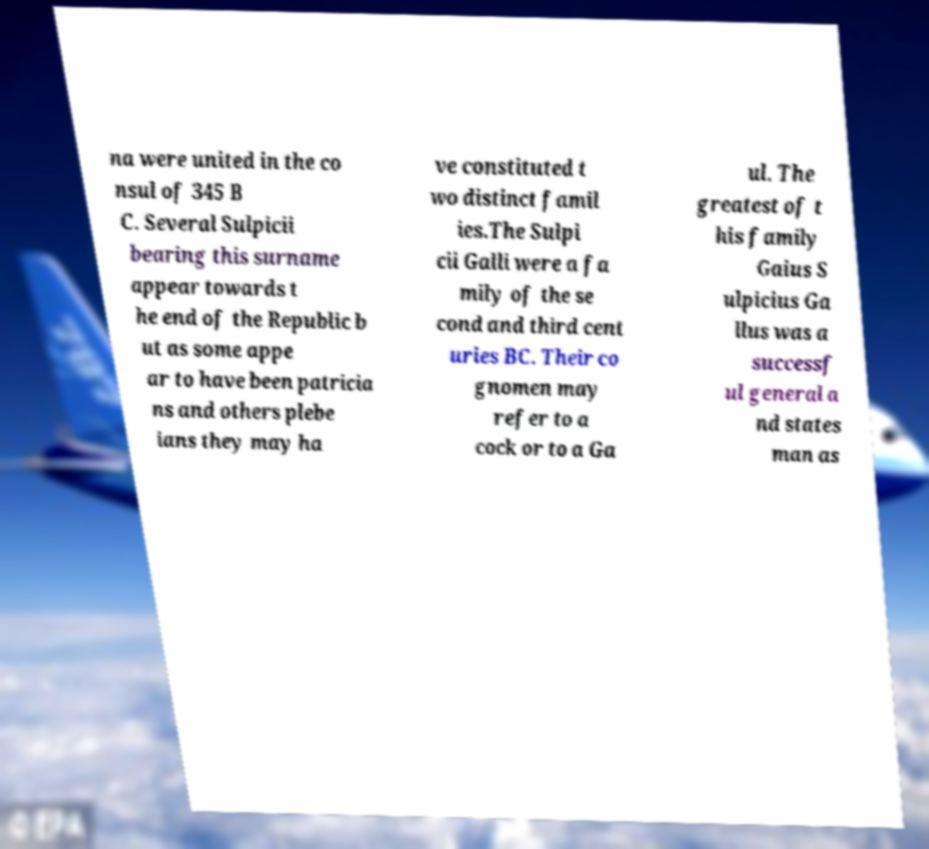Could you extract and type out the text from this image? na were united in the co nsul of 345 B C. Several Sulpicii bearing this surname appear towards t he end of the Republic b ut as some appe ar to have been patricia ns and others plebe ians they may ha ve constituted t wo distinct famil ies.The Sulpi cii Galli were a fa mily of the se cond and third cent uries BC. Their co gnomen may refer to a cock or to a Ga ul. The greatest of t his family Gaius S ulpicius Ga llus was a successf ul general a nd states man as 